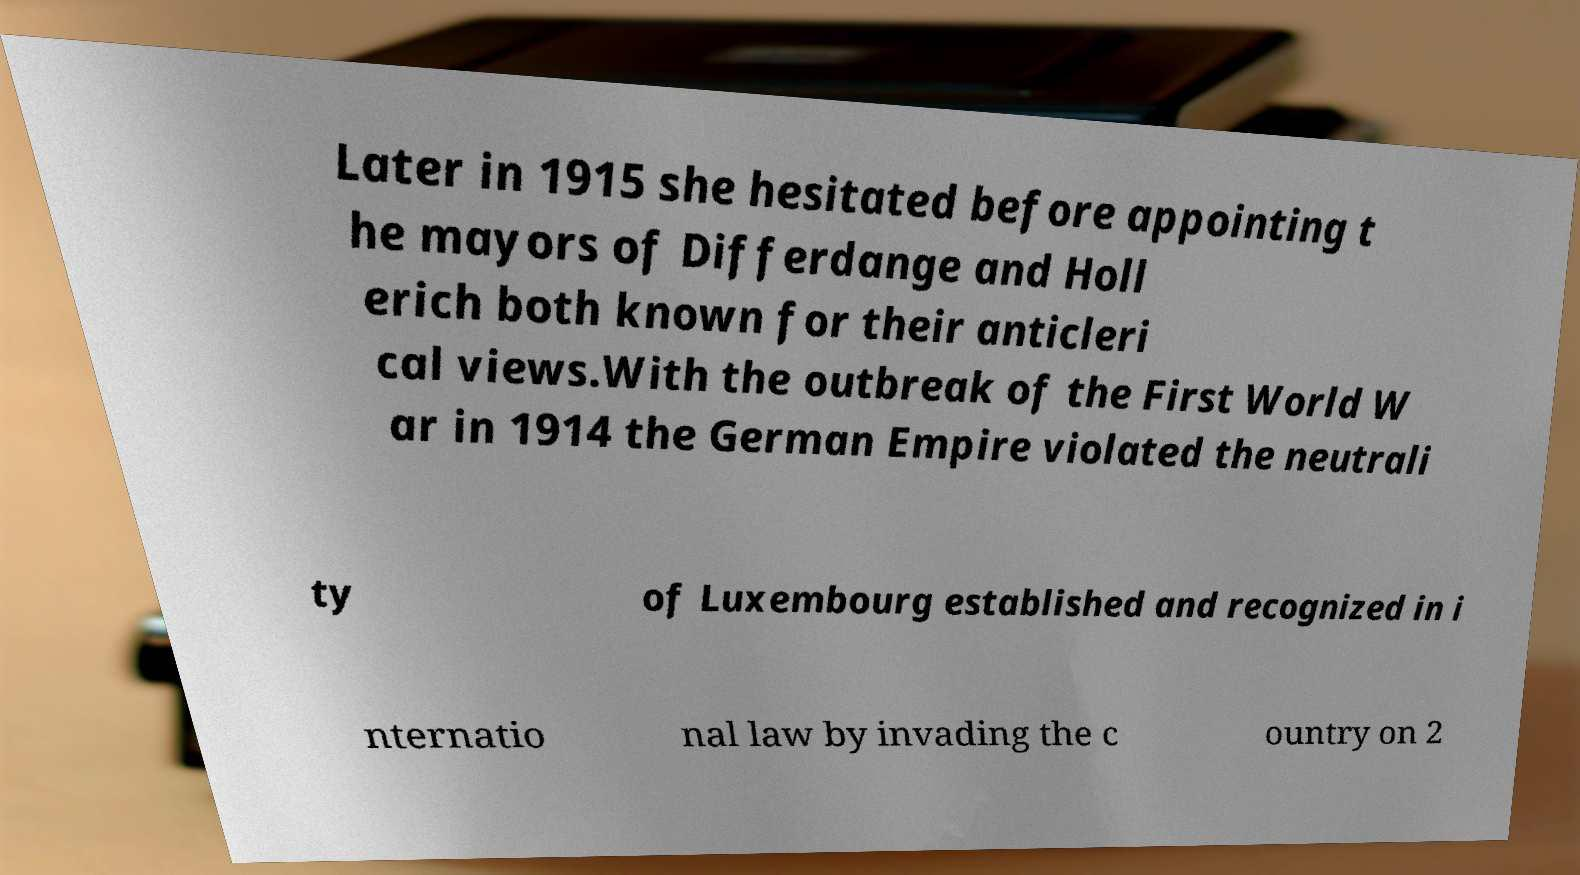Could you assist in decoding the text presented in this image and type it out clearly? Later in 1915 she hesitated before appointing t he mayors of Differdange and Holl erich both known for their anticleri cal views.With the outbreak of the First World W ar in 1914 the German Empire violated the neutrali ty of Luxembourg established and recognized in i nternatio nal law by invading the c ountry on 2 